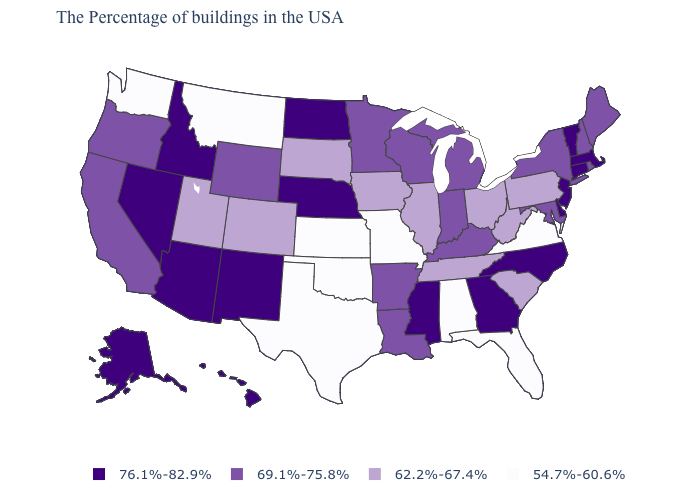Does Louisiana have the same value as Kentucky?
Answer briefly. Yes. Name the states that have a value in the range 62.2%-67.4%?
Concise answer only. Pennsylvania, South Carolina, West Virginia, Ohio, Tennessee, Illinois, Iowa, South Dakota, Colorado, Utah. What is the value of Indiana?
Answer briefly. 69.1%-75.8%. Which states have the lowest value in the USA?
Concise answer only. Virginia, Florida, Alabama, Missouri, Kansas, Oklahoma, Texas, Montana, Washington. Does Idaho have the highest value in the USA?
Answer briefly. Yes. What is the value of Alaska?
Answer briefly. 76.1%-82.9%. Does Pennsylvania have a higher value than Alabama?
Quick response, please. Yes. What is the lowest value in states that border Kentucky?
Short answer required. 54.7%-60.6%. Among the states that border Massachusetts , which have the lowest value?
Be succinct. Rhode Island, New Hampshire, New York. Which states have the lowest value in the South?
Short answer required. Virginia, Florida, Alabama, Oklahoma, Texas. Name the states that have a value in the range 54.7%-60.6%?
Quick response, please. Virginia, Florida, Alabama, Missouri, Kansas, Oklahoma, Texas, Montana, Washington. What is the lowest value in states that border Connecticut?
Short answer required. 69.1%-75.8%. What is the value of Maryland?
Give a very brief answer. 69.1%-75.8%. What is the highest value in states that border Oklahoma?
Answer briefly. 76.1%-82.9%. What is the value of Missouri?
Write a very short answer. 54.7%-60.6%. 